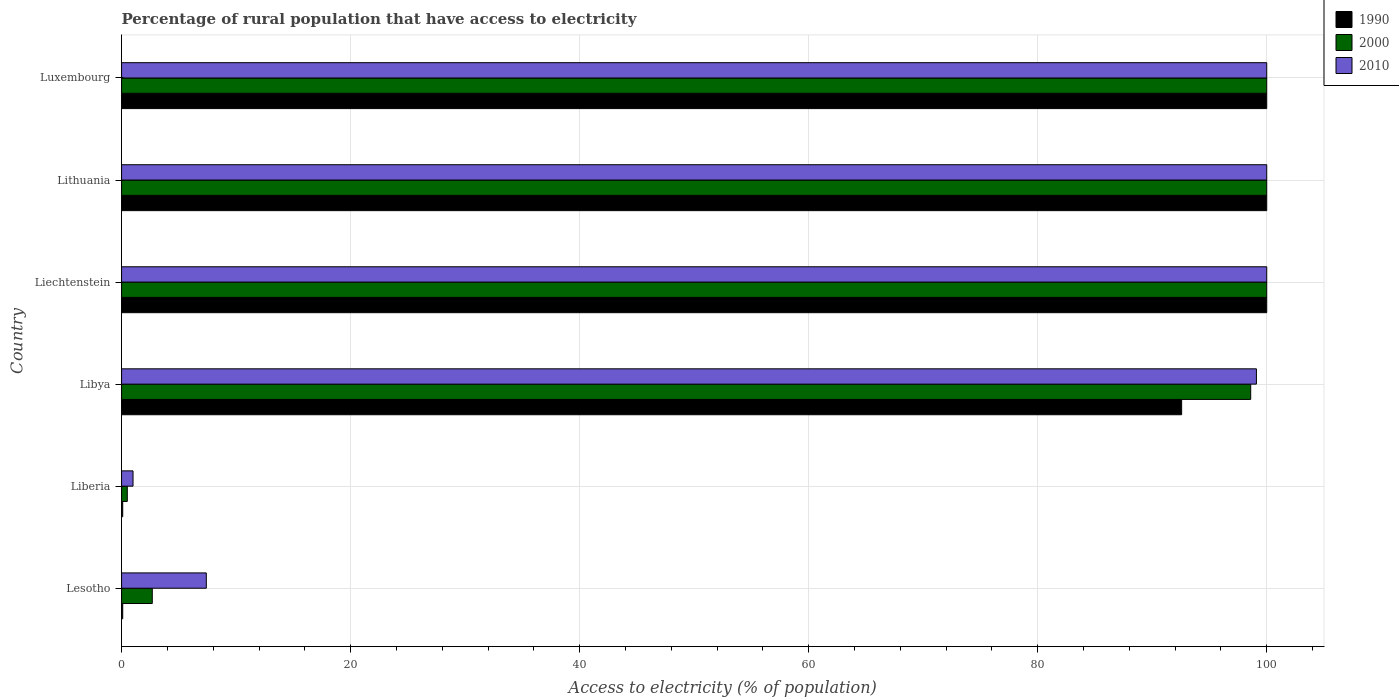How many different coloured bars are there?
Give a very brief answer. 3. Are the number of bars on each tick of the Y-axis equal?
Give a very brief answer. Yes. How many bars are there on the 4th tick from the bottom?
Ensure brevity in your answer.  3. What is the label of the 6th group of bars from the top?
Ensure brevity in your answer.  Lesotho. In how many cases, is the number of bars for a given country not equal to the number of legend labels?
Provide a succinct answer. 0. What is the percentage of rural population that have access to electricity in 1990 in Lithuania?
Your answer should be very brief. 100. Across all countries, what is the maximum percentage of rural population that have access to electricity in 2010?
Offer a very short reply. 100. Across all countries, what is the minimum percentage of rural population that have access to electricity in 2010?
Your response must be concise. 1. In which country was the percentage of rural population that have access to electricity in 2000 maximum?
Provide a short and direct response. Liechtenstein. In which country was the percentage of rural population that have access to electricity in 2010 minimum?
Give a very brief answer. Liberia. What is the total percentage of rural population that have access to electricity in 2000 in the graph?
Make the answer very short. 401.78. What is the difference between the percentage of rural population that have access to electricity in 2010 in Liechtenstein and that in Lithuania?
Provide a succinct answer. 0. What is the difference between the percentage of rural population that have access to electricity in 1990 in Liberia and the percentage of rural population that have access to electricity in 2000 in Liechtenstein?
Your answer should be very brief. -99.9. What is the average percentage of rural population that have access to electricity in 2010 per country?
Provide a short and direct response. 67.92. What is the difference between the percentage of rural population that have access to electricity in 2010 and percentage of rural population that have access to electricity in 1990 in Lesotho?
Offer a terse response. 7.3. In how many countries, is the percentage of rural population that have access to electricity in 2000 greater than 28 %?
Provide a short and direct response. 4. Is the difference between the percentage of rural population that have access to electricity in 2010 in Lesotho and Liechtenstein greater than the difference between the percentage of rural population that have access to electricity in 1990 in Lesotho and Liechtenstein?
Your answer should be very brief. Yes. What is the difference between the highest and the lowest percentage of rural population that have access to electricity in 2000?
Give a very brief answer. 99.5. What does the 3rd bar from the top in Liberia represents?
Your response must be concise. 1990. What does the 3rd bar from the bottom in Libya represents?
Provide a short and direct response. 2010. Is it the case that in every country, the sum of the percentage of rural population that have access to electricity in 1990 and percentage of rural population that have access to electricity in 2010 is greater than the percentage of rural population that have access to electricity in 2000?
Give a very brief answer. Yes. Are all the bars in the graph horizontal?
Your answer should be very brief. Yes. How many countries are there in the graph?
Your answer should be compact. 6. Does the graph contain grids?
Your answer should be very brief. Yes. Where does the legend appear in the graph?
Your answer should be very brief. Top right. How many legend labels are there?
Keep it short and to the point. 3. How are the legend labels stacked?
Provide a succinct answer. Vertical. What is the title of the graph?
Provide a short and direct response. Percentage of rural population that have access to electricity. What is the label or title of the X-axis?
Your answer should be very brief. Access to electricity (% of population). What is the Access to electricity (% of population) in 1990 in Lesotho?
Your response must be concise. 0.1. What is the Access to electricity (% of population) of 2000 in Lesotho?
Provide a short and direct response. 2.68. What is the Access to electricity (% of population) of 1990 in Liberia?
Your response must be concise. 0.1. What is the Access to electricity (% of population) of 2000 in Liberia?
Keep it short and to the point. 0.5. What is the Access to electricity (% of population) in 2010 in Liberia?
Offer a very short reply. 1. What is the Access to electricity (% of population) in 1990 in Libya?
Give a very brief answer. 92.57. What is the Access to electricity (% of population) in 2000 in Libya?
Ensure brevity in your answer.  98.6. What is the Access to electricity (% of population) of 2010 in Libya?
Give a very brief answer. 99.1. What is the Access to electricity (% of population) of 2000 in Liechtenstein?
Keep it short and to the point. 100. What is the Access to electricity (% of population) in 2000 in Luxembourg?
Offer a very short reply. 100. Across all countries, what is the maximum Access to electricity (% of population) in 1990?
Your answer should be very brief. 100. Across all countries, what is the maximum Access to electricity (% of population) in 2000?
Make the answer very short. 100. Across all countries, what is the minimum Access to electricity (% of population) in 1990?
Make the answer very short. 0.1. Across all countries, what is the minimum Access to electricity (% of population) in 2000?
Ensure brevity in your answer.  0.5. What is the total Access to electricity (% of population) in 1990 in the graph?
Your answer should be very brief. 392.77. What is the total Access to electricity (% of population) of 2000 in the graph?
Make the answer very short. 401.78. What is the total Access to electricity (% of population) of 2010 in the graph?
Make the answer very short. 407.5. What is the difference between the Access to electricity (% of population) of 1990 in Lesotho and that in Liberia?
Ensure brevity in your answer.  0. What is the difference between the Access to electricity (% of population) of 2000 in Lesotho and that in Liberia?
Give a very brief answer. 2.18. What is the difference between the Access to electricity (% of population) in 1990 in Lesotho and that in Libya?
Provide a succinct answer. -92.47. What is the difference between the Access to electricity (% of population) of 2000 in Lesotho and that in Libya?
Your response must be concise. -95.92. What is the difference between the Access to electricity (% of population) in 2010 in Lesotho and that in Libya?
Provide a succinct answer. -91.7. What is the difference between the Access to electricity (% of population) in 1990 in Lesotho and that in Liechtenstein?
Provide a short and direct response. -99.9. What is the difference between the Access to electricity (% of population) in 2000 in Lesotho and that in Liechtenstein?
Your response must be concise. -97.32. What is the difference between the Access to electricity (% of population) of 2010 in Lesotho and that in Liechtenstein?
Make the answer very short. -92.6. What is the difference between the Access to electricity (% of population) in 1990 in Lesotho and that in Lithuania?
Your answer should be very brief. -99.9. What is the difference between the Access to electricity (% of population) of 2000 in Lesotho and that in Lithuania?
Make the answer very short. -97.32. What is the difference between the Access to electricity (% of population) in 2010 in Lesotho and that in Lithuania?
Your answer should be compact. -92.6. What is the difference between the Access to electricity (% of population) of 1990 in Lesotho and that in Luxembourg?
Ensure brevity in your answer.  -99.9. What is the difference between the Access to electricity (% of population) of 2000 in Lesotho and that in Luxembourg?
Give a very brief answer. -97.32. What is the difference between the Access to electricity (% of population) in 2010 in Lesotho and that in Luxembourg?
Offer a very short reply. -92.6. What is the difference between the Access to electricity (% of population) of 1990 in Liberia and that in Libya?
Make the answer very short. -92.47. What is the difference between the Access to electricity (% of population) of 2000 in Liberia and that in Libya?
Your answer should be very brief. -98.1. What is the difference between the Access to electricity (% of population) of 2010 in Liberia and that in Libya?
Provide a succinct answer. -98.1. What is the difference between the Access to electricity (% of population) of 1990 in Liberia and that in Liechtenstein?
Your answer should be very brief. -99.9. What is the difference between the Access to electricity (% of population) of 2000 in Liberia and that in Liechtenstein?
Provide a succinct answer. -99.5. What is the difference between the Access to electricity (% of population) of 2010 in Liberia and that in Liechtenstein?
Provide a short and direct response. -99. What is the difference between the Access to electricity (% of population) of 1990 in Liberia and that in Lithuania?
Offer a very short reply. -99.9. What is the difference between the Access to electricity (% of population) of 2000 in Liberia and that in Lithuania?
Your response must be concise. -99.5. What is the difference between the Access to electricity (% of population) in 2010 in Liberia and that in Lithuania?
Your response must be concise. -99. What is the difference between the Access to electricity (% of population) of 1990 in Liberia and that in Luxembourg?
Offer a very short reply. -99.9. What is the difference between the Access to electricity (% of population) in 2000 in Liberia and that in Luxembourg?
Provide a succinct answer. -99.5. What is the difference between the Access to electricity (% of population) in 2010 in Liberia and that in Luxembourg?
Offer a very short reply. -99. What is the difference between the Access to electricity (% of population) of 1990 in Libya and that in Liechtenstein?
Offer a terse response. -7.43. What is the difference between the Access to electricity (% of population) in 1990 in Libya and that in Lithuania?
Provide a succinct answer. -7.43. What is the difference between the Access to electricity (% of population) of 2000 in Libya and that in Lithuania?
Ensure brevity in your answer.  -1.4. What is the difference between the Access to electricity (% of population) in 1990 in Libya and that in Luxembourg?
Keep it short and to the point. -7.43. What is the difference between the Access to electricity (% of population) in 2000 in Libya and that in Luxembourg?
Provide a succinct answer. -1.4. What is the difference between the Access to electricity (% of population) in 2010 in Libya and that in Luxembourg?
Provide a succinct answer. -0.9. What is the difference between the Access to electricity (% of population) of 1990 in Liechtenstein and that in Lithuania?
Make the answer very short. 0. What is the difference between the Access to electricity (% of population) of 2000 in Liechtenstein and that in Lithuania?
Provide a succinct answer. 0. What is the difference between the Access to electricity (% of population) of 1990 in Liechtenstein and that in Luxembourg?
Ensure brevity in your answer.  0. What is the difference between the Access to electricity (% of population) of 2000 in Liechtenstein and that in Luxembourg?
Your answer should be compact. 0. What is the difference between the Access to electricity (% of population) of 2010 in Liechtenstein and that in Luxembourg?
Make the answer very short. 0. What is the difference between the Access to electricity (% of population) in 1990 in Lesotho and the Access to electricity (% of population) in 2000 in Liberia?
Make the answer very short. -0.4. What is the difference between the Access to electricity (% of population) in 2000 in Lesotho and the Access to electricity (% of population) in 2010 in Liberia?
Give a very brief answer. 1.68. What is the difference between the Access to electricity (% of population) in 1990 in Lesotho and the Access to electricity (% of population) in 2000 in Libya?
Keep it short and to the point. -98.5. What is the difference between the Access to electricity (% of population) in 1990 in Lesotho and the Access to electricity (% of population) in 2010 in Libya?
Your response must be concise. -99. What is the difference between the Access to electricity (% of population) of 2000 in Lesotho and the Access to electricity (% of population) of 2010 in Libya?
Offer a terse response. -96.42. What is the difference between the Access to electricity (% of population) of 1990 in Lesotho and the Access to electricity (% of population) of 2000 in Liechtenstein?
Your response must be concise. -99.9. What is the difference between the Access to electricity (% of population) in 1990 in Lesotho and the Access to electricity (% of population) in 2010 in Liechtenstein?
Provide a short and direct response. -99.9. What is the difference between the Access to electricity (% of population) in 2000 in Lesotho and the Access to electricity (% of population) in 2010 in Liechtenstein?
Your answer should be compact. -97.32. What is the difference between the Access to electricity (% of population) of 1990 in Lesotho and the Access to electricity (% of population) of 2000 in Lithuania?
Your answer should be compact. -99.9. What is the difference between the Access to electricity (% of population) in 1990 in Lesotho and the Access to electricity (% of population) in 2010 in Lithuania?
Provide a short and direct response. -99.9. What is the difference between the Access to electricity (% of population) of 2000 in Lesotho and the Access to electricity (% of population) of 2010 in Lithuania?
Give a very brief answer. -97.32. What is the difference between the Access to electricity (% of population) in 1990 in Lesotho and the Access to electricity (% of population) in 2000 in Luxembourg?
Provide a short and direct response. -99.9. What is the difference between the Access to electricity (% of population) in 1990 in Lesotho and the Access to electricity (% of population) in 2010 in Luxembourg?
Provide a short and direct response. -99.9. What is the difference between the Access to electricity (% of population) in 2000 in Lesotho and the Access to electricity (% of population) in 2010 in Luxembourg?
Keep it short and to the point. -97.32. What is the difference between the Access to electricity (% of population) of 1990 in Liberia and the Access to electricity (% of population) of 2000 in Libya?
Make the answer very short. -98.5. What is the difference between the Access to electricity (% of population) of 1990 in Liberia and the Access to electricity (% of population) of 2010 in Libya?
Your answer should be compact. -99. What is the difference between the Access to electricity (% of population) in 2000 in Liberia and the Access to electricity (% of population) in 2010 in Libya?
Keep it short and to the point. -98.6. What is the difference between the Access to electricity (% of population) in 1990 in Liberia and the Access to electricity (% of population) in 2000 in Liechtenstein?
Offer a very short reply. -99.9. What is the difference between the Access to electricity (% of population) of 1990 in Liberia and the Access to electricity (% of population) of 2010 in Liechtenstein?
Offer a very short reply. -99.9. What is the difference between the Access to electricity (% of population) in 2000 in Liberia and the Access to electricity (% of population) in 2010 in Liechtenstein?
Provide a short and direct response. -99.5. What is the difference between the Access to electricity (% of population) in 1990 in Liberia and the Access to electricity (% of population) in 2000 in Lithuania?
Keep it short and to the point. -99.9. What is the difference between the Access to electricity (% of population) of 1990 in Liberia and the Access to electricity (% of population) of 2010 in Lithuania?
Offer a very short reply. -99.9. What is the difference between the Access to electricity (% of population) in 2000 in Liberia and the Access to electricity (% of population) in 2010 in Lithuania?
Your answer should be compact. -99.5. What is the difference between the Access to electricity (% of population) in 1990 in Liberia and the Access to electricity (% of population) in 2000 in Luxembourg?
Provide a succinct answer. -99.9. What is the difference between the Access to electricity (% of population) of 1990 in Liberia and the Access to electricity (% of population) of 2010 in Luxembourg?
Provide a short and direct response. -99.9. What is the difference between the Access to electricity (% of population) of 2000 in Liberia and the Access to electricity (% of population) of 2010 in Luxembourg?
Keep it short and to the point. -99.5. What is the difference between the Access to electricity (% of population) of 1990 in Libya and the Access to electricity (% of population) of 2000 in Liechtenstein?
Offer a very short reply. -7.43. What is the difference between the Access to electricity (% of population) in 1990 in Libya and the Access to electricity (% of population) in 2010 in Liechtenstein?
Provide a succinct answer. -7.43. What is the difference between the Access to electricity (% of population) of 2000 in Libya and the Access to electricity (% of population) of 2010 in Liechtenstein?
Ensure brevity in your answer.  -1.4. What is the difference between the Access to electricity (% of population) in 1990 in Libya and the Access to electricity (% of population) in 2000 in Lithuania?
Offer a terse response. -7.43. What is the difference between the Access to electricity (% of population) in 1990 in Libya and the Access to electricity (% of population) in 2010 in Lithuania?
Provide a short and direct response. -7.43. What is the difference between the Access to electricity (% of population) of 2000 in Libya and the Access to electricity (% of population) of 2010 in Lithuania?
Provide a succinct answer. -1.4. What is the difference between the Access to electricity (% of population) of 1990 in Libya and the Access to electricity (% of population) of 2000 in Luxembourg?
Provide a short and direct response. -7.43. What is the difference between the Access to electricity (% of population) in 1990 in Libya and the Access to electricity (% of population) in 2010 in Luxembourg?
Ensure brevity in your answer.  -7.43. What is the difference between the Access to electricity (% of population) in 2000 in Libya and the Access to electricity (% of population) in 2010 in Luxembourg?
Your response must be concise. -1.4. What is the difference between the Access to electricity (% of population) in 1990 in Liechtenstein and the Access to electricity (% of population) in 2010 in Lithuania?
Your response must be concise. 0. What is the difference between the Access to electricity (% of population) in 1990 in Liechtenstein and the Access to electricity (% of population) in 2010 in Luxembourg?
Your response must be concise. 0. What is the difference between the Access to electricity (% of population) of 1990 in Lithuania and the Access to electricity (% of population) of 2010 in Luxembourg?
Give a very brief answer. 0. What is the difference between the Access to electricity (% of population) of 2000 in Lithuania and the Access to electricity (% of population) of 2010 in Luxembourg?
Offer a very short reply. 0. What is the average Access to electricity (% of population) of 1990 per country?
Your response must be concise. 65.46. What is the average Access to electricity (% of population) in 2000 per country?
Your answer should be very brief. 66.96. What is the average Access to electricity (% of population) of 2010 per country?
Give a very brief answer. 67.92. What is the difference between the Access to electricity (% of population) in 1990 and Access to electricity (% of population) in 2000 in Lesotho?
Provide a short and direct response. -2.58. What is the difference between the Access to electricity (% of population) of 1990 and Access to electricity (% of population) of 2010 in Lesotho?
Provide a short and direct response. -7.3. What is the difference between the Access to electricity (% of population) in 2000 and Access to electricity (% of population) in 2010 in Lesotho?
Provide a short and direct response. -4.72. What is the difference between the Access to electricity (% of population) in 1990 and Access to electricity (% of population) in 2000 in Liberia?
Provide a short and direct response. -0.4. What is the difference between the Access to electricity (% of population) in 1990 and Access to electricity (% of population) in 2000 in Libya?
Offer a terse response. -6.03. What is the difference between the Access to electricity (% of population) of 1990 and Access to electricity (% of population) of 2010 in Libya?
Offer a very short reply. -6.53. What is the difference between the Access to electricity (% of population) of 2000 and Access to electricity (% of population) of 2010 in Libya?
Make the answer very short. -0.5. What is the difference between the Access to electricity (% of population) in 1990 and Access to electricity (% of population) in 2000 in Liechtenstein?
Your answer should be compact. 0. What is the difference between the Access to electricity (% of population) in 1990 and Access to electricity (% of population) in 2010 in Liechtenstein?
Your answer should be very brief. 0. What is the difference between the Access to electricity (% of population) of 1990 and Access to electricity (% of population) of 2000 in Lithuania?
Give a very brief answer. 0. What is the difference between the Access to electricity (% of population) in 2000 and Access to electricity (% of population) in 2010 in Lithuania?
Ensure brevity in your answer.  0. What is the difference between the Access to electricity (% of population) of 1990 and Access to electricity (% of population) of 2000 in Luxembourg?
Your answer should be compact. 0. What is the difference between the Access to electricity (% of population) of 1990 and Access to electricity (% of population) of 2010 in Luxembourg?
Provide a short and direct response. 0. What is the difference between the Access to electricity (% of population) in 2000 and Access to electricity (% of population) in 2010 in Luxembourg?
Make the answer very short. 0. What is the ratio of the Access to electricity (% of population) of 1990 in Lesotho to that in Liberia?
Give a very brief answer. 1. What is the ratio of the Access to electricity (% of population) in 2000 in Lesotho to that in Liberia?
Your response must be concise. 5.36. What is the ratio of the Access to electricity (% of population) in 2010 in Lesotho to that in Liberia?
Offer a terse response. 7.4. What is the ratio of the Access to electricity (% of population) of 1990 in Lesotho to that in Libya?
Offer a very short reply. 0. What is the ratio of the Access to electricity (% of population) in 2000 in Lesotho to that in Libya?
Ensure brevity in your answer.  0.03. What is the ratio of the Access to electricity (% of population) in 2010 in Lesotho to that in Libya?
Give a very brief answer. 0.07. What is the ratio of the Access to electricity (% of population) in 2000 in Lesotho to that in Liechtenstein?
Provide a succinct answer. 0.03. What is the ratio of the Access to electricity (% of population) in 2010 in Lesotho to that in Liechtenstein?
Offer a very short reply. 0.07. What is the ratio of the Access to electricity (% of population) in 1990 in Lesotho to that in Lithuania?
Give a very brief answer. 0. What is the ratio of the Access to electricity (% of population) of 2000 in Lesotho to that in Lithuania?
Provide a succinct answer. 0.03. What is the ratio of the Access to electricity (% of population) of 2010 in Lesotho to that in Lithuania?
Ensure brevity in your answer.  0.07. What is the ratio of the Access to electricity (% of population) of 2000 in Lesotho to that in Luxembourg?
Provide a short and direct response. 0.03. What is the ratio of the Access to electricity (% of population) in 2010 in Lesotho to that in Luxembourg?
Ensure brevity in your answer.  0.07. What is the ratio of the Access to electricity (% of population) of 1990 in Liberia to that in Libya?
Your answer should be very brief. 0. What is the ratio of the Access to electricity (% of population) of 2000 in Liberia to that in Libya?
Keep it short and to the point. 0.01. What is the ratio of the Access to electricity (% of population) of 2010 in Liberia to that in Libya?
Make the answer very short. 0.01. What is the ratio of the Access to electricity (% of population) of 1990 in Liberia to that in Liechtenstein?
Your answer should be compact. 0. What is the ratio of the Access to electricity (% of population) of 2000 in Liberia to that in Liechtenstein?
Offer a terse response. 0.01. What is the ratio of the Access to electricity (% of population) in 2000 in Liberia to that in Lithuania?
Ensure brevity in your answer.  0.01. What is the ratio of the Access to electricity (% of population) of 1990 in Liberia to that in Luxembourg?
Make the answer very short. 0. What is the ratio of the Access to electricity (% of population) of 2000 in Liberia to that in Luxembourg?
Provide a succinct answer. 0.01. What is the ratio of the Access to electricity (% of population) in 2010 in Liberia to that in Luxembourg?
Ensure brevity in your answer.  0.01. What is the ratio of the Access to electricity (% of population) of 1990 in Libya to that in Liechtenstein?
Keep it short and to the point. 0.93. What is the ratio of the Access to electricity (% of population) in 2000 in Libya to that in Liechtenstein?
Give a very brief answer. 0.99. What is the ratio of the Access to electricity (% of population) in 1990 in Libya to that in Lithuania?
Your response must be concise. 0.93. What is the ratio of the Access to electricity (% of population) in 1990 in Libya to that in Luxembourg?
Your response must be concise. 0.93. What is the ratio of the Access to electricity (% of population) of 2010 in Libya to that in Luxembourg?
Provide a short and direct response. 0.99. What is the ratio of the Access to electricity (% of population) of 2000 in Liechtenstein to that in Lithuania?
Provide a succinct answer. 1. What is the ratio of the Access to electricity (% of population) of 2010 in Liechtenstein to that in Lithuania?
Keep it short and to the point. 1. What is the ratio of the Access to electricity (% of population) of 1990 in Liechtenstein to that in Luxembourg?
Your response must be concise. 1. What is the ratio of the Access to electricity (% of population) in 1990 in Lithuania to that in Luxembourg?
Provide a short and direct response. 1. What is the ratio of the Access to electricity (% of population) in 2000 in Lithuania to that in Luxembourg?
Provide a short and direct response. 1. What is the difference between the highest and the second highest Access to electricity (% of population) in 1990?
Your response must be concise. 0. What is the difference between the highest and the second highest Access to electricity (% of population) in 2010?
Provide a short and direct response. 0. What is the difference between the highest and the lowest Access to electricity (% of population) in 1990?
Provide a short and direct response. 99.9. What is the difference between the highest and the lowest Access to electricity (% of population) of 2000?
Provide a short and direct response. 99.5. 